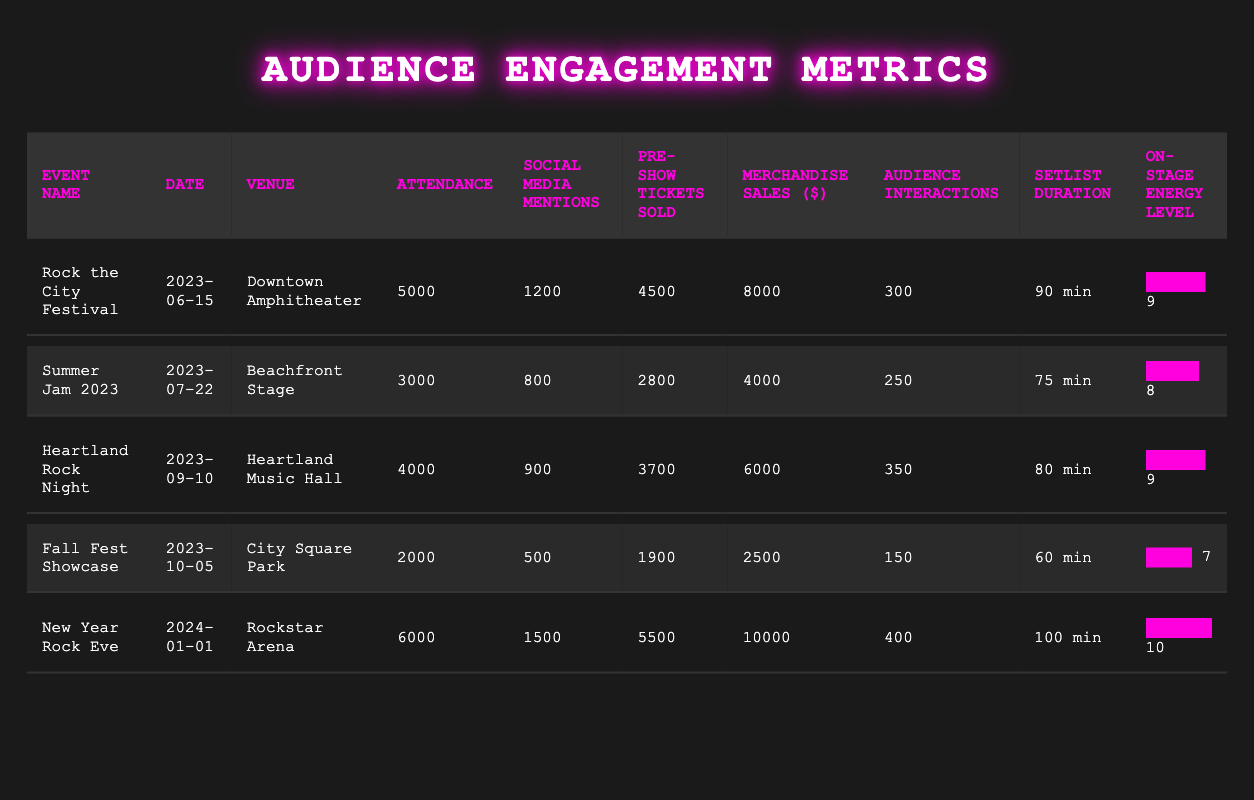What was the venue for "Heartland Rock Night"? The table lists the venue information for each event, and under "Heartland Rock Night," the venue is specified as "Heartland Music Hall."
Answer: Heartland Music Hall Which event had the highest merchandise sales? By comparing the merchandise sales figures in the table, "New Year Rock Eve" has the highest sales at $10,000, while the next highest is "Rock the City Festival" at $8,000.
Answer: New Year Rock Eve What is the average attendance across all events? To find the average attendance, we sum the attendance figures: (5000 + 3000 + 4000 + 2000 + 6000) = 20000. We then divide by the number of events (5): 20000 / 5 = 4000.
Answer: 4000 Did "Fall Fest Showcase" have more audience interactions than "Summer Jam 2023"? In the table, "Fall Fest Showcase" has 150 audience interactions, while "Summer Jam 2023" has 250. Since 150 is less than 250, the statement is false.
Answer: No Which event had the longest setlist duration? The setlist durations listed are "90 min," "75 min," "80 min," "60 min," and "100 min." The longest duration is for "New Year Rock Eve," which is 100 minutes.
Answer: New Year Rock Eve Is the energy level for "Rock the City Festival" equal to or greater than the energy level for "Heartland Rock Night"? The energy level for "Rock the City Festival" is 9, and for "Heartland Rock Night," it is also 9. Since they are equal, the statement is true.
Answer: Yes What is the total number of social media mentions across all events? Adding the social media mentions from the table gives: 1200 + 800 + 900 + 500 + 1500 = 3900.
Answer: 3900 Which event had the lowest pre-show tickets sold, and how many were sold? The pre-show tickets sold for each event are 4500, 2800, 3700, 1900, and 5500. The lowest figure is for "Fall Fest Showcase," with 1900 tickets sold.
Answer: Fall Fest Showcase, 1900 In how many events did the audience interactions exceed 300? By reviewing the audience interaction figures (300, 250, 350, 150, and 400), the only event where interactions exceed 300 is "New Year Rock Eve" and "Heartland Rock Night." Thus, there are 2 events.
Answer: 2 